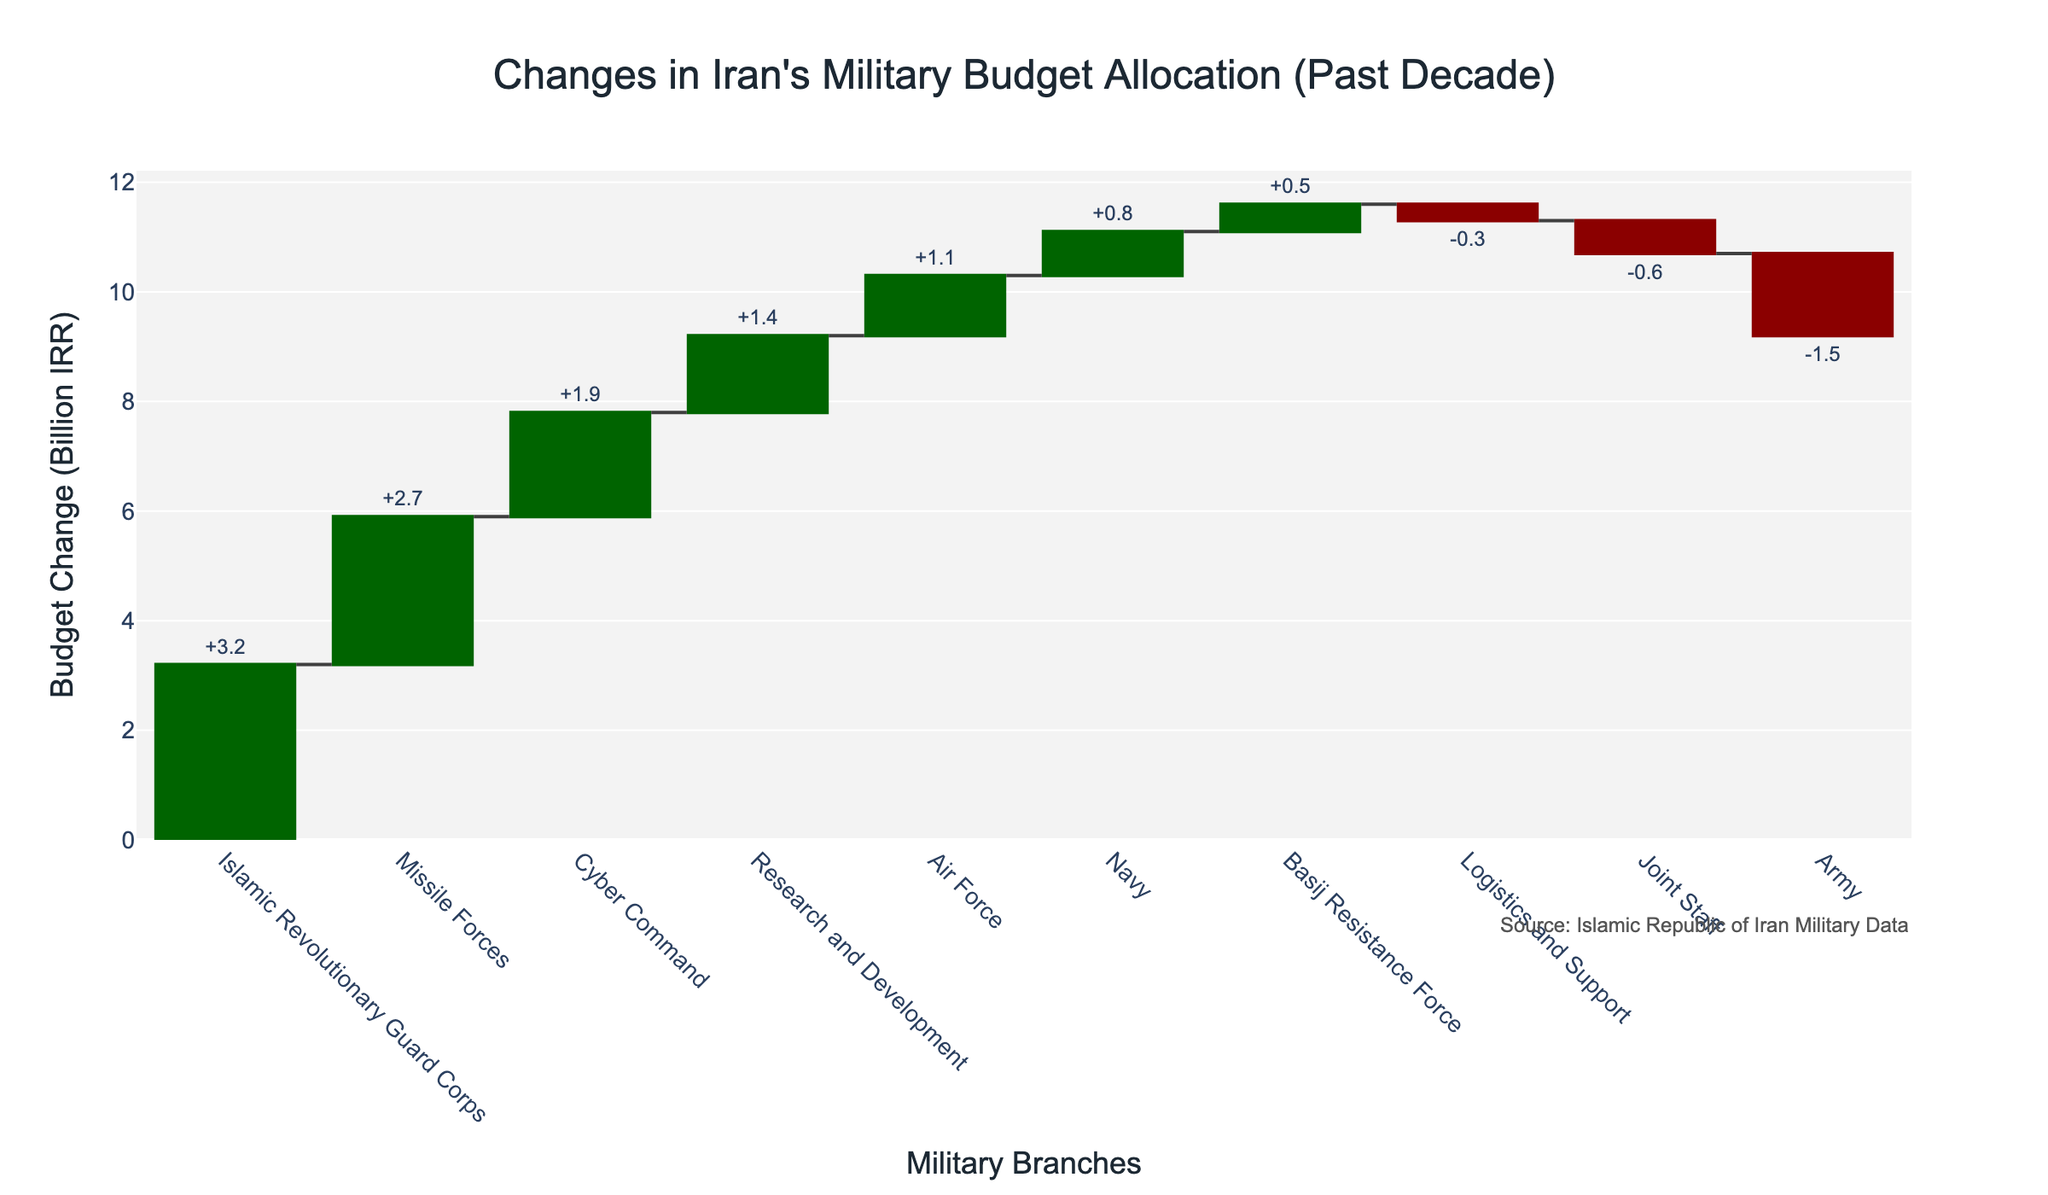What is the title of the chart? The title is provided at the top center of the chart, which describes the data being visualized.
Answer: Changes in Iran's Military Budget Allocation (Past Decade) Which military branch received the highest budget increase? By looking at the bar with the tallest positive change, we can identify it.
Answer: Islamic Revolutionary Guard Corps How much did the budget for the Army change? By locating the 'Army' category on the x-axis and checking its corresponding change value given in the text position outside the bar.
Answer: -1.5 billion IRR What is the total budget change combining the Navy and Air Force? Identify the changes for both Navy (+0.8) and Air Force (+1.1), then sum them up: 0.8 + 1.1 = 1.9.
Answer: 1.9 billion IRR Which branch experienced a budget decrease? Identify the bars with negative values and check their respective branches.
Answer: Army and Joint Staff How much more did the Cyber Command receive compared to the Basij Resistance Force? Find the budget change for both Cyber Command (+1.9) and Basij Resistance Force (+0.5), then calculate the difference: 1.9 - 0.5 = 1.4.
Answer: 1.4 billion IRR What's the budget change for the Research and Development branch? Locate the 'Research and Development' branch on the x-axis and read the corresponding change in value.
Answer: +1.4 billion IRR How much budget change did the Missile Forces receive, and how does it compare to the Air Force? Identify the changes for both Missile Forces (+2.7) and Air Force (+1.1), then compare: 2.7 is greater than 1.1.
Answer: Missile Forces received 2.7 billion IRR, which is more than the Air Force's 1.1 billion IRR Which branches received a budget increase that is greater than 1.0 billion IRR? Identify the branches with a positive budget increase higher than 1.0 from the bars: Islamic Revolutionary Guard Corps (+3.2), Missile Forces (+2.7), Cyber Command (+1.9), Air Force (+1.1), and Research and Development (+1.4).
Answer: Islamic Revolutionary Guard Corps, Missile Forces, Cyber Command, Air Force, and Research and Development 